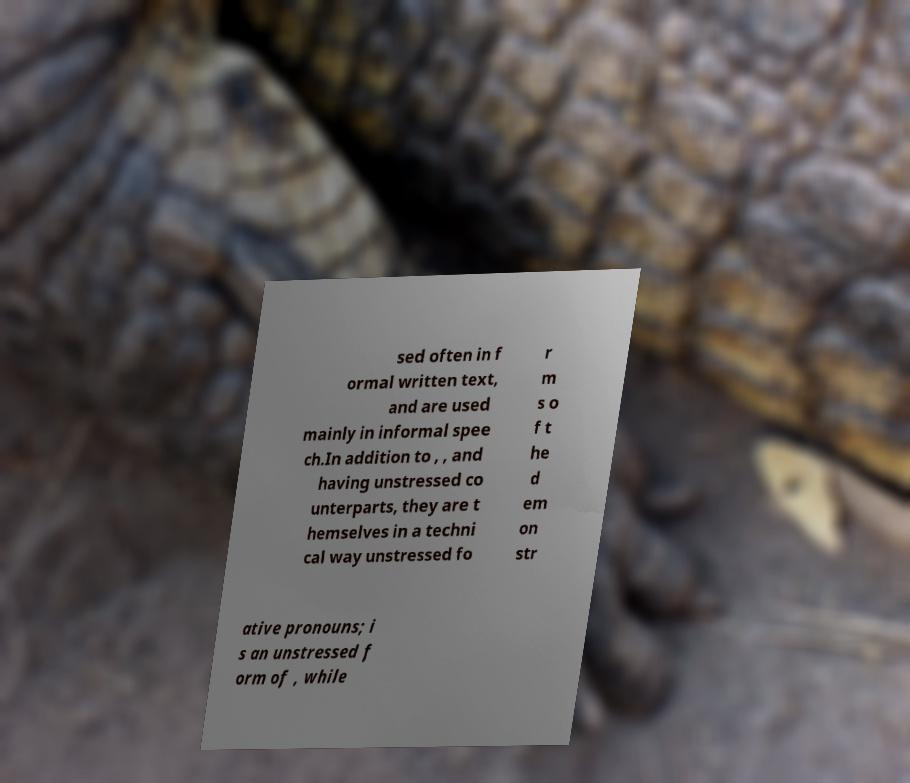For documentation purposes, I need the text within this image transcribed. Could you provide that? sed often in f ormal written text, and are used mainly in informal spee ch.In addition to , , and having unstressed co unterparts, they are t hemselves in a techni cal way unstressed fo r m s o f t he d em on str ative pronouns; i s an unstressed f orm of , while 